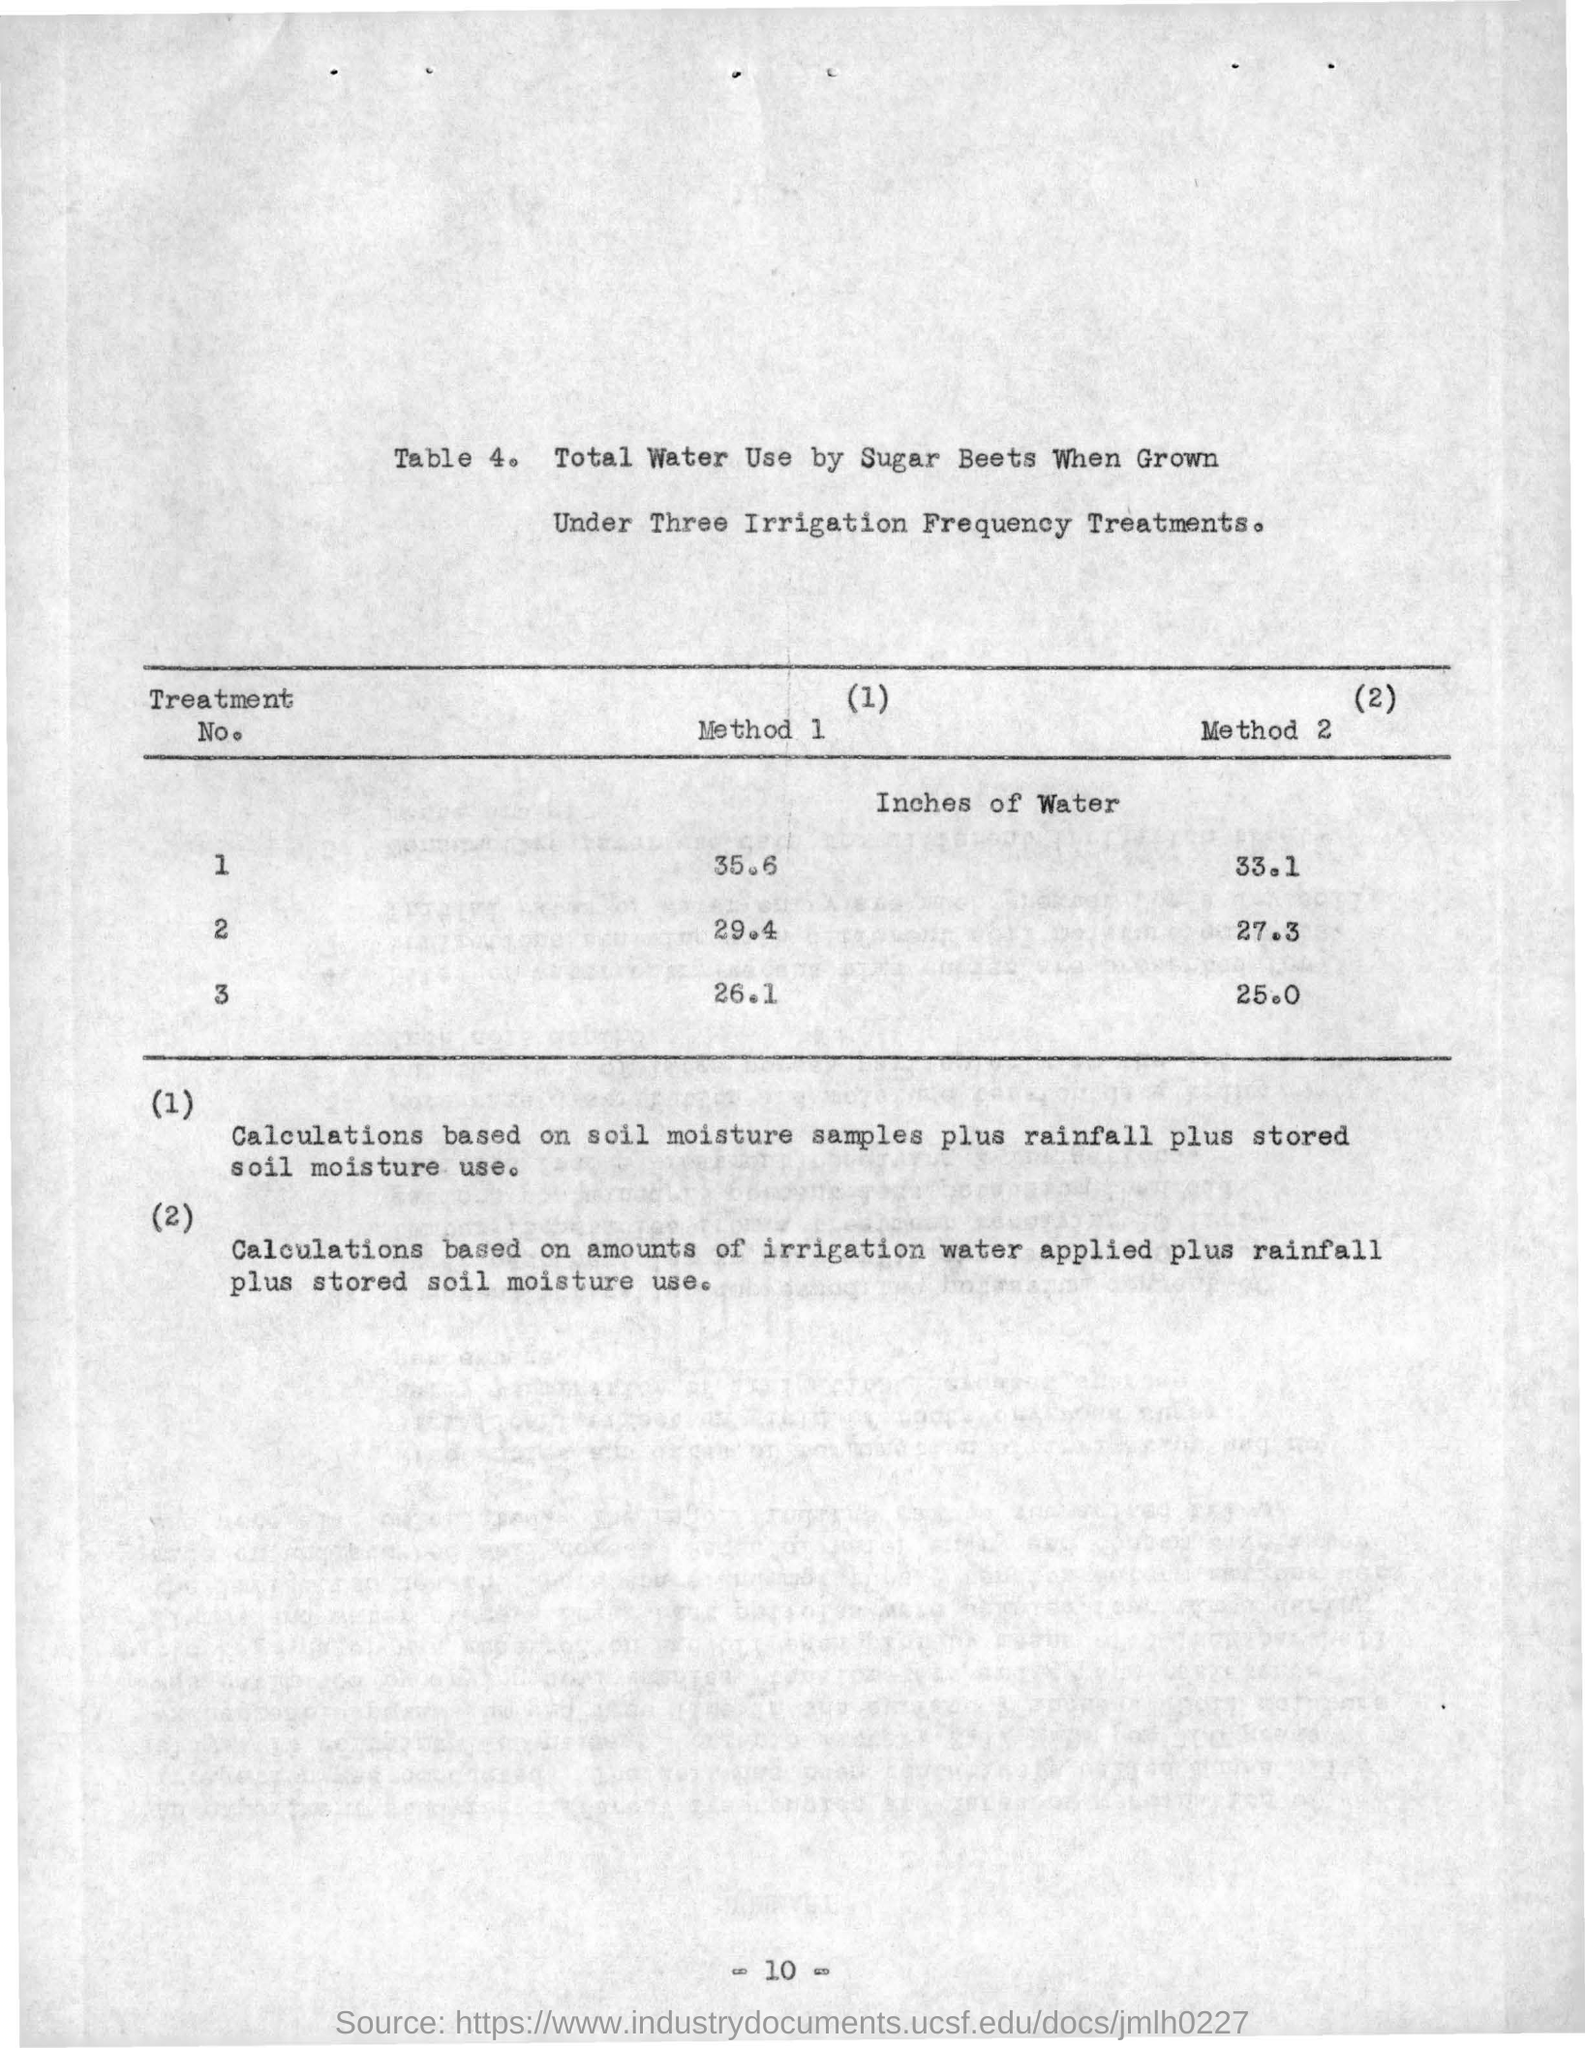What is the table number ?
Your response must be concise. Table 4. How many Methods included in this table ?
Your response must be concise. 2. 